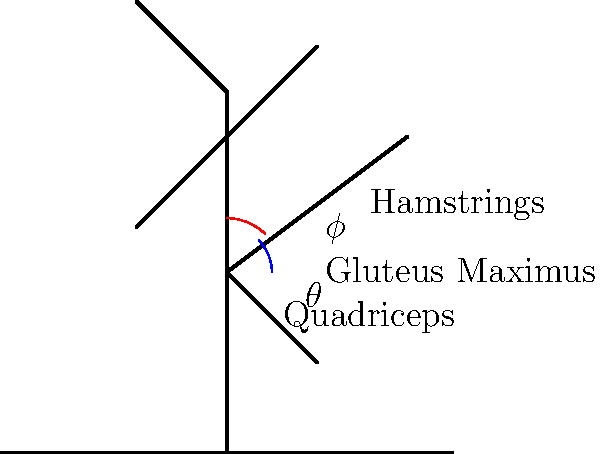In the arabesque position shown, which muscle group is primarily responsible for maintaining the extended leg position, and what is the approximate angle ($\theta$) between the dancer's torso and the raised leg? To answer this question, we need to analyze the biomechanics of the arabesque position:

1. Muscle activation:
   - The primary muscle group responsible for maintaining the extended leg position is the hip extensors.
   - The main hip extensor muscles are:
     a) Gluteus Maximus
     b) Hamstrings (Biceps Femoris, Semitendinosus, Semimembranosus)

2. Joint angles:
   - The angle $\theta$ is formed between the dancer's torso and the raised leg.
   - In a typical arabesque position, this angle ranges from 90° to 120°, depending on the dancer's flexibility and technique.

3. Biomechanical analysis:
   - The Gluteus Maximus is the primary muscle responsible for hip extension in this position.
   - The Hamstrings assist in hip extension and also help maintain knee extension.
   - The Quadriceps on the supporting leg work isometrically to maintain balance and stability.

4. Angle estimation:
   - Based on the diagram, the angle $\theta$ appears to be approximately 90° to 100°.
   - This is a common range for a well-executed arabesque position in classical ballet.

5. Additional considerations:
   - Core muscles (abdominals and lower back muscles) are also engaged to maintain proper posture and balance.
   - The supporting leg's muscles, particularly the Quadriceps and calf muscles, work to maintain stability and balance.

Given this analysis, the primary muscle group responsible for maintaining the extended leg position is the hip extensors, with the Gluteus Maximus being the main contributor. The approximate angle $\theta$ between the dancer's torso and the raised leg is 90°-100°.
Answer: Hip extensors (primarily Gluteus Maximus); 90°-100° 